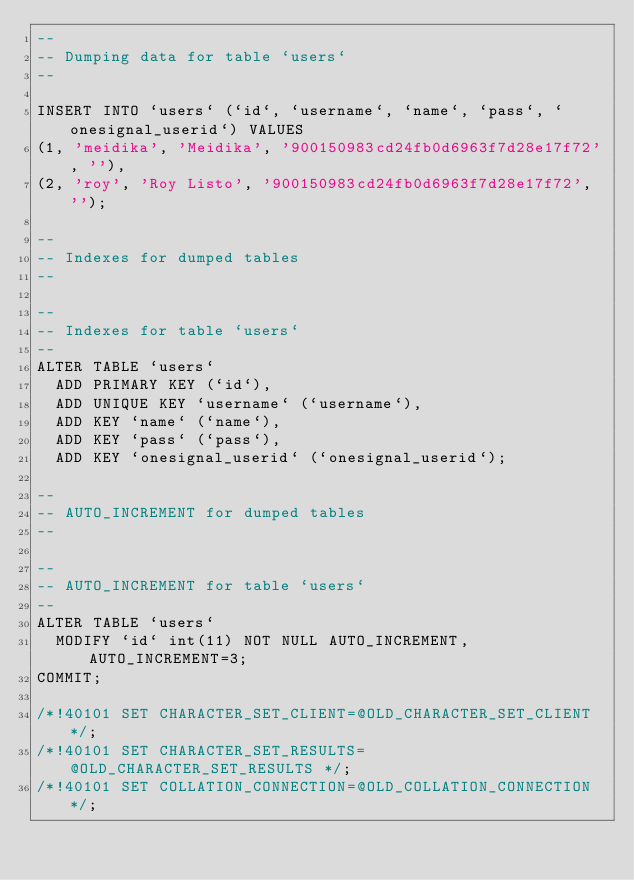<code> <loc_0><loc_0><loc_500><loc_500><_SQL_>--
-- Dumping data for table `users`
--

INSERT INTO `users` (`id`, `username`, `name`, `pass`, `onesignal_userid`) VALUES
(1, 'meidika', 'Meidika', '900150983cd24fb0d6963f7d28e17f72', ''),
(2, 'roy', 'Roy Listo', '900150983cd24fb0d6963f7d28e17f72', '');

--
-- Indexes for dumped tables
--

--
-- Indexes for table `users`
--
ALTER TABLE `users`
  ADD PRIMARY KEY (`id`),
  ADD UNIQUE KEY `username` (`username`),
  ADD KEY `name` (`name`),
  ADD KEY `pass` (`pass`),
  ADD KEY `onesignal_userid` (`onesignal_userid`);

--
-- AUTO_INCREMENT for dumped tables
--

--
-- AUTO_INCREMENT for table `users`
--
ALTER TABLE `users`
  MODIFY `id` int(11) NOT NULL AUTO_INCREMENT, AUTO_INCREMENT=3;
COMMIT;

/*!40101 SET CHARACTER_SET_CLIENT=@OLD_CHARACTER_SET_CLIENT */;
/*!40101 SET CHARACTER_SET_RESULTS=@OLD_CHARACTER_SET_RESULTS */;
/*!40101 SET COLLATION_CONNECTION=@OLD_COLLATION_CONNECTION */;
</code> 